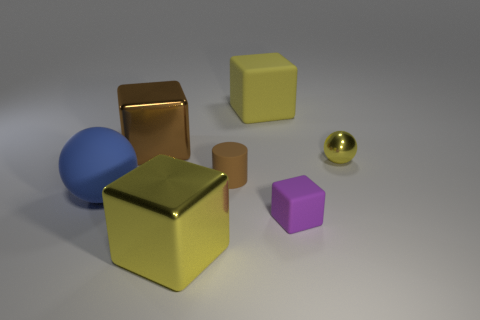There is a small object that is the same color as the large matte block; what material is it? The small object that shares its color with the large matte block appears to be a small gold-colored ball. Given the context of the image, which looks like a 3D render, it's challenging to accurately determine the material without additional information. However, it could be interpreted as a polished metal, possibly gold or brass, based on its reflective properties. 